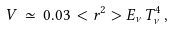Convert formula to latex. <formula><loc_0><loc_0><loc_500><loc_500>V \, \simeq \, 0 . 0 3 \, < r ^ { 2 } > E _ { \nu } T _ { \nu } ^ { 4 } \, ,</formula> 